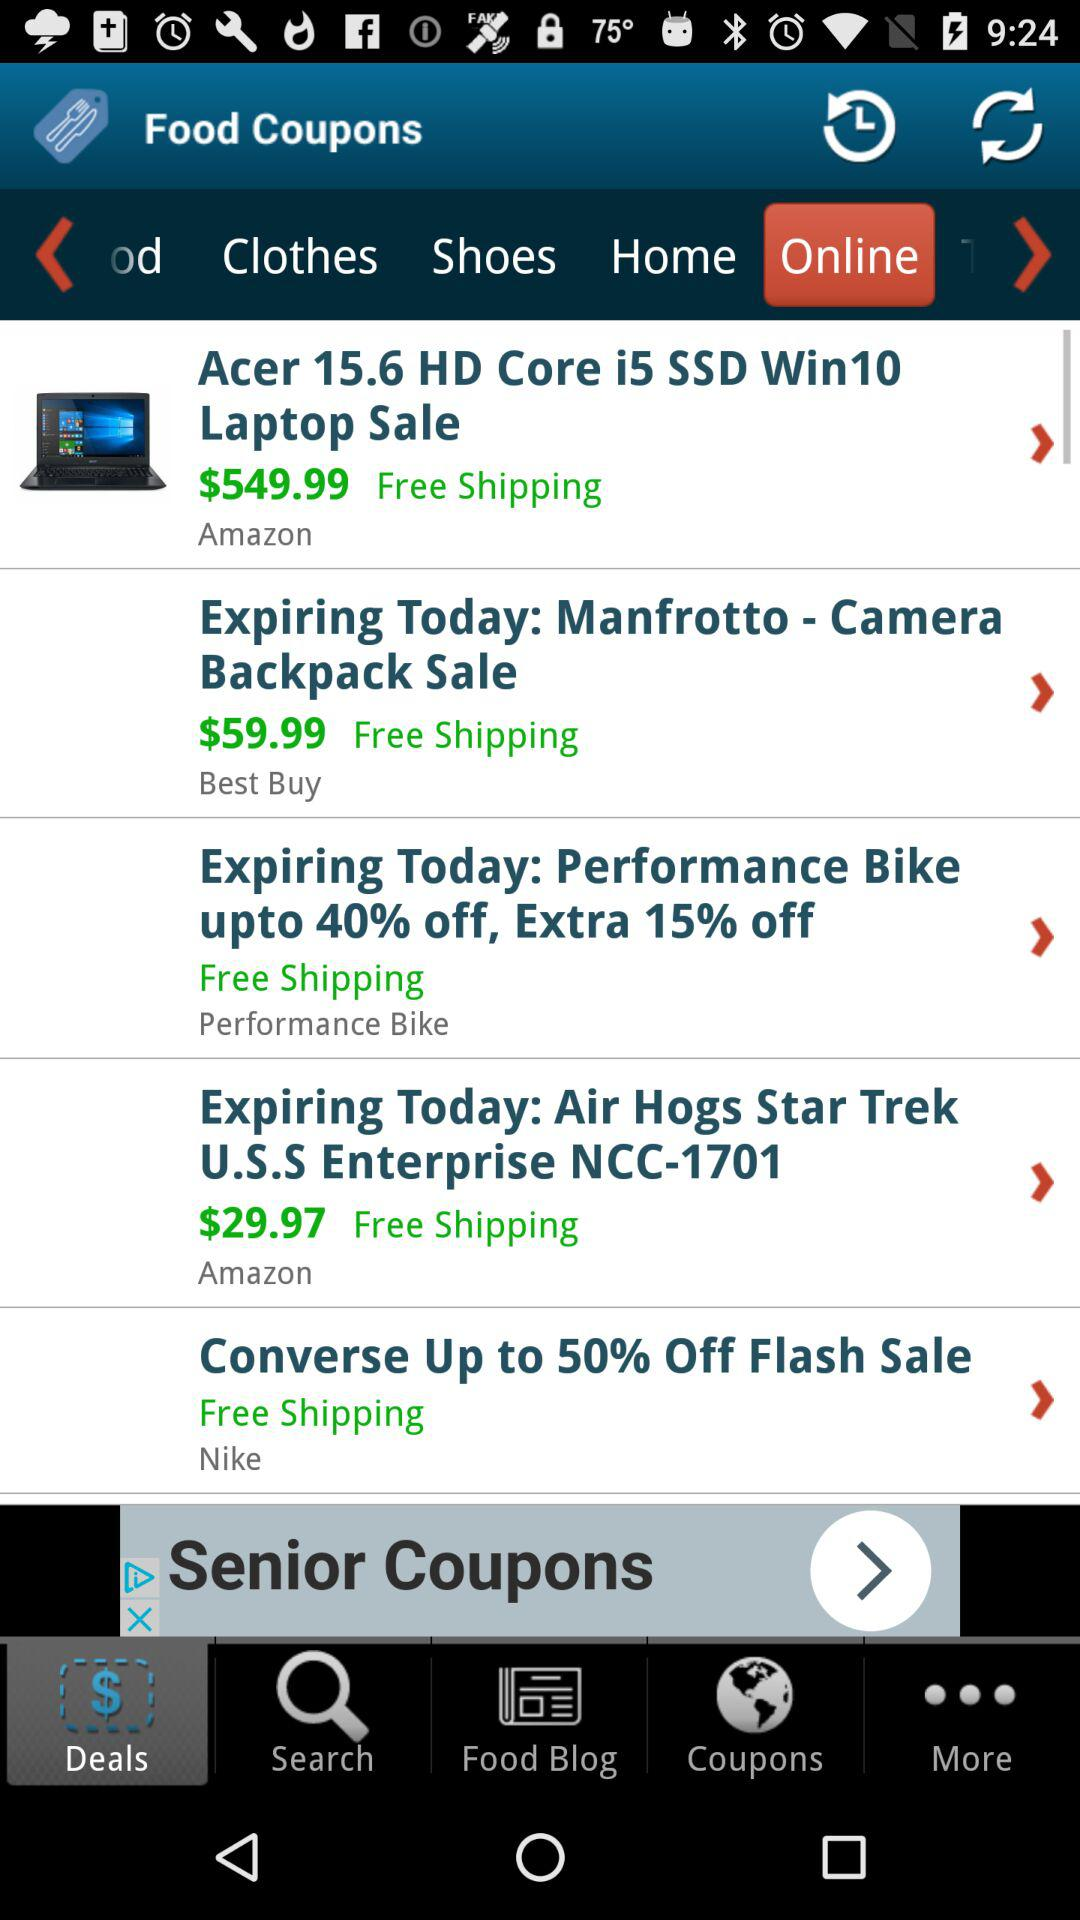Which tab is selected? The selected tabs are "Deals" and "Online". 